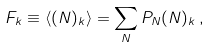<formula> <loc_0><loc_0><loc_500><loc_500>F _ { k } \equiv \langle ( N ) _ { k } \rangle = \sum _ { N } P _ { N } ( N ) _ { k } \, ,</formula> 